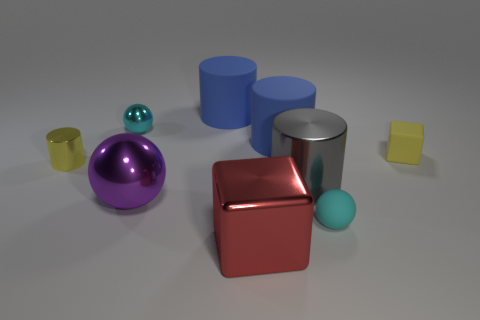The small metallic sphere has what color?
Your response must be concise. Cyan. What is the shape of the small object that is on the right side of the small rubber ball?
Make the answer very short. Cube. Is there a big thing behind the metallic sphere in front of the tiny yellow object that is on the right side of the big red object?
Your response must be concise. Yes. Is there any other thing that has the same shape as the tiny cyan matte object?
Make the answer very short. Yes. Are there any purple metal blocks?
Ensure brevity in your answer.  No. Do the thing to the right of the small cyan rubber ball and the block that is in front of the yellow cylinder have the same material?
Provide a succinct answer. No. What is the size of the yellow thing that is on the right side of the sphere that is behind the cube that is behind the rubber ball?
Provide a succinct answer. Small. How many big cylinders have the same material as the purple thing?
Keep it short and to the point. 1. Are there fewer big rubber cylinders than large yellow rubber objects?
Ensure brevity in your answer.  No. What size is the other metallic thing that is the same shape as the large gray metal object?
Make the answer very short. Small. 